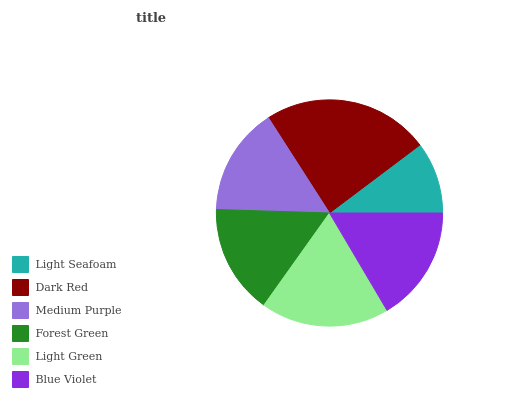Is Light Seafoam the minimum?
Answer yes or no. Yes. Is Dark Red the maximum?
Answer yes or no. Yes. Is Medium Purple the minimum?
Answer yes or no. No. Is Medium Purple the maximum?
Answer yes or no. No. Is Dark Red greater than Medium Purple?
Answer yes or no. Yes. Is Medium Purple less than Dark Red?
Answer yes or no. Yes. Is Medium Purple greater than Dark Red?
Answer yes or no. No. Is Dark Red less than Medium Purple?
Answer yes or no. No. Is Blue Violet the high median?
Answer yes or no. Yes. Is Forest Green the low median?
Answer yes or no. Yes. Is Light Green the high median?
Answer yes or no. No. Is Dark Red the low median?
Answer yes or no. No. 